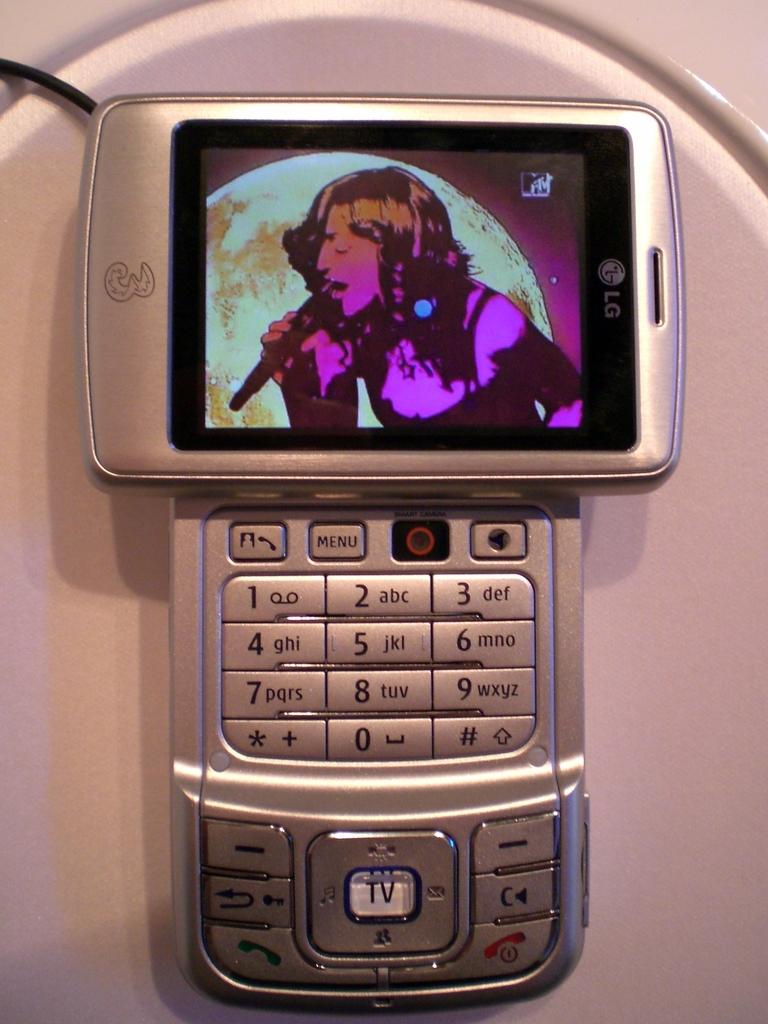What brand is the phone?
Provide a short and direct response. Lg. 